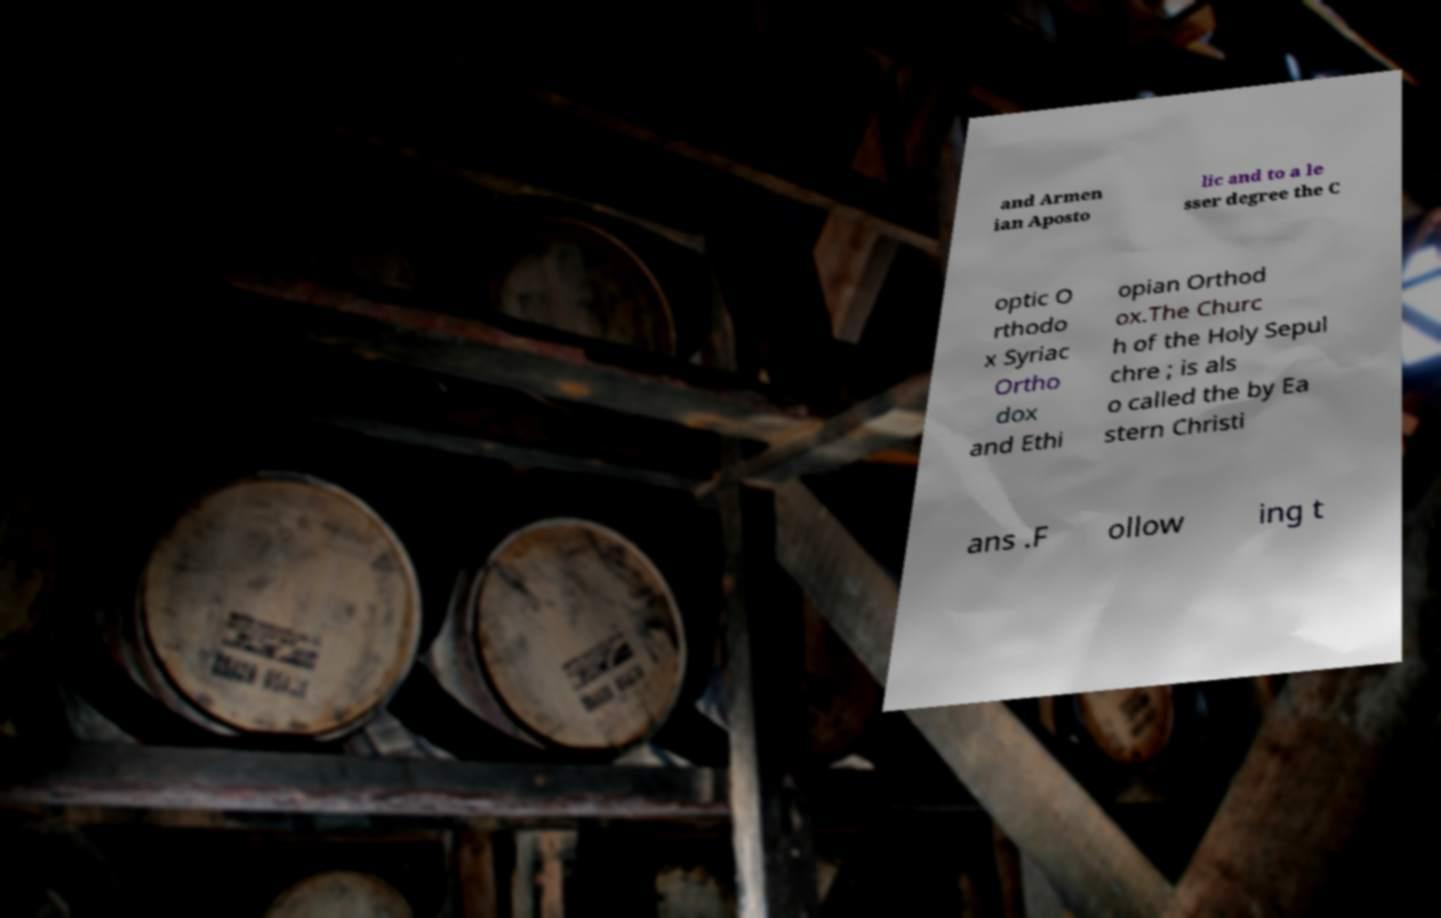Can you read and provide the text displayed in the image?This photo seems to have some interesting text. Can you extract and type it out for me? and Armen ian Aposto lic and to a le sser degree the C optic O rthodo x Syriac Ortho dox and Ethi opian Orthod ox.The Churc h of the Holy Sepul chre ; is als o called the by Ea stern Christi ans .F ollow ing t 